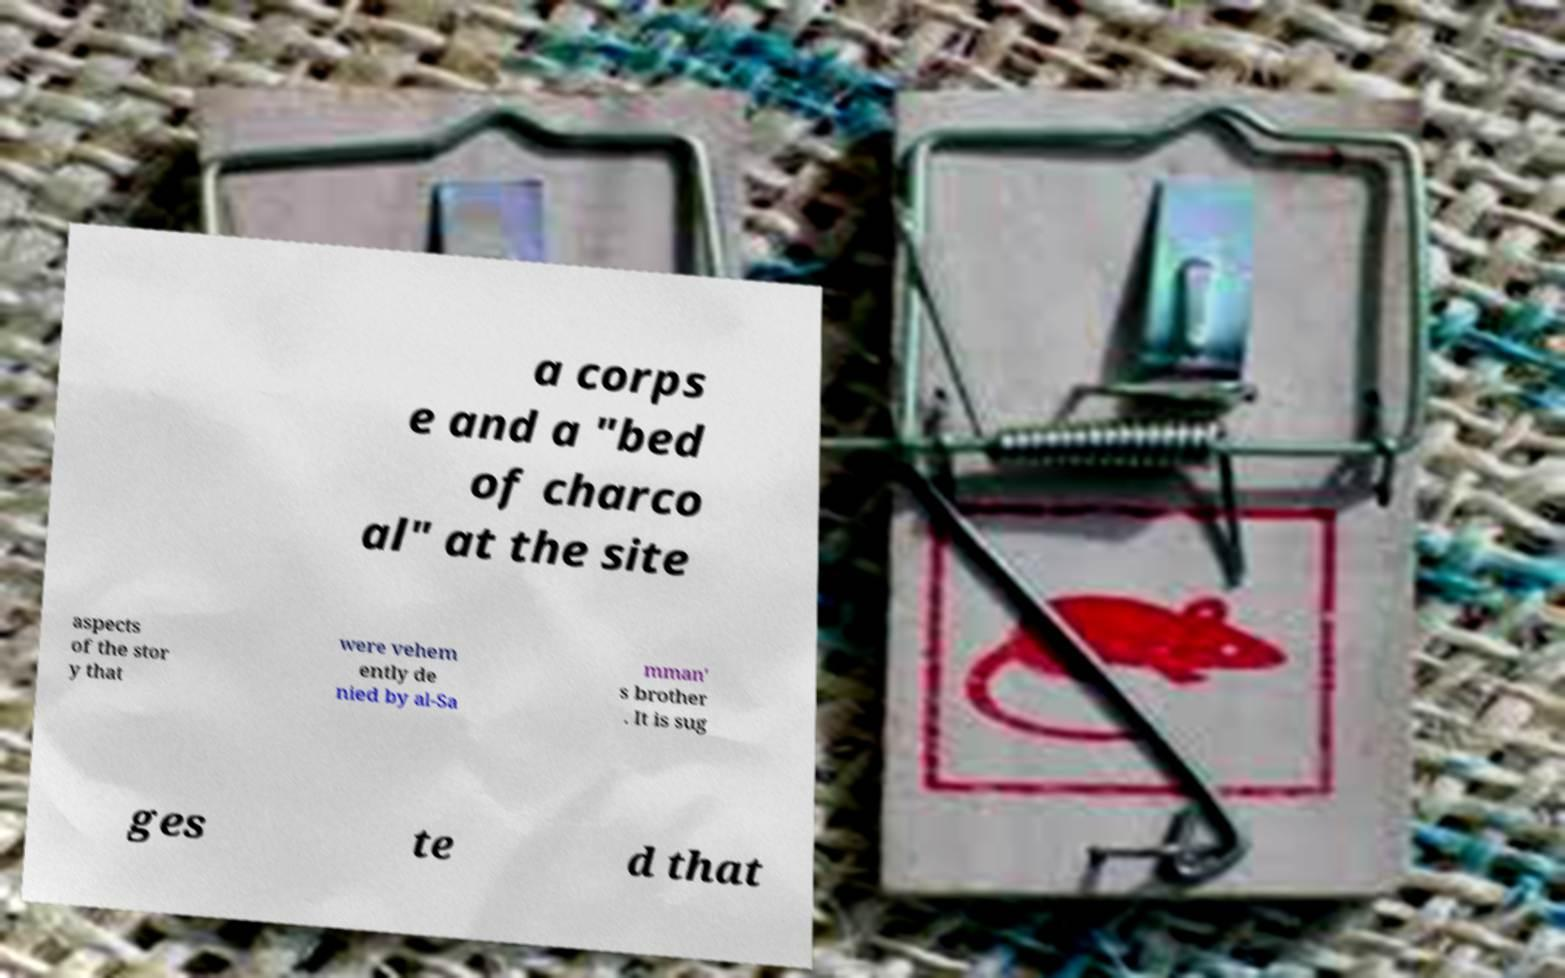Can you read and provide the text displayed in the image?This photo seems to have some interesting text. Can you extract and type it out for me? a corps e and a "bed of charco al" at the site aspects of the stor y that were vehem ently de nied by al-Sa mman' s brother . It is sug ges te d that 